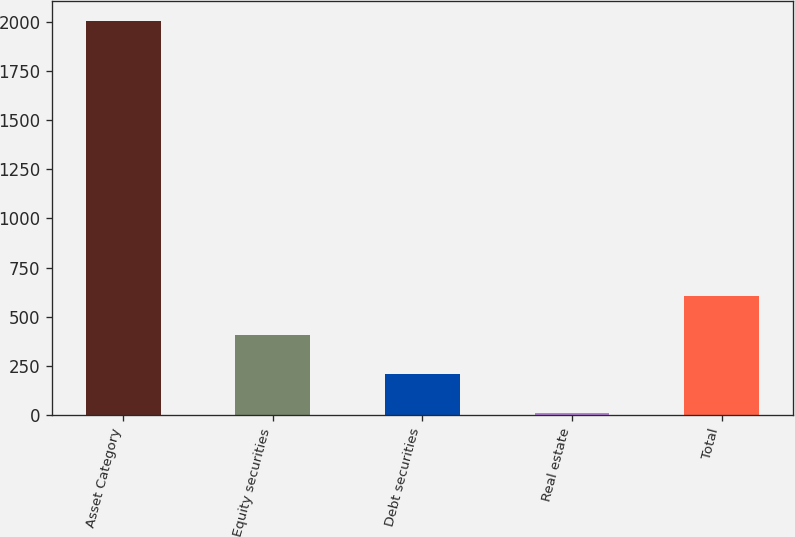Convert chart. <chart><loc_0><loc_0><loc_500><loc_500><bar_chart><fcel>Asset Category<fcel>Equity securities<fcel>Debt securities<fcel>Real estate<fcel>Total<nl><fcel>2005<fcel>408.2<fcel>208.6<fcel>9<fcel>607.8<nl></chart> 